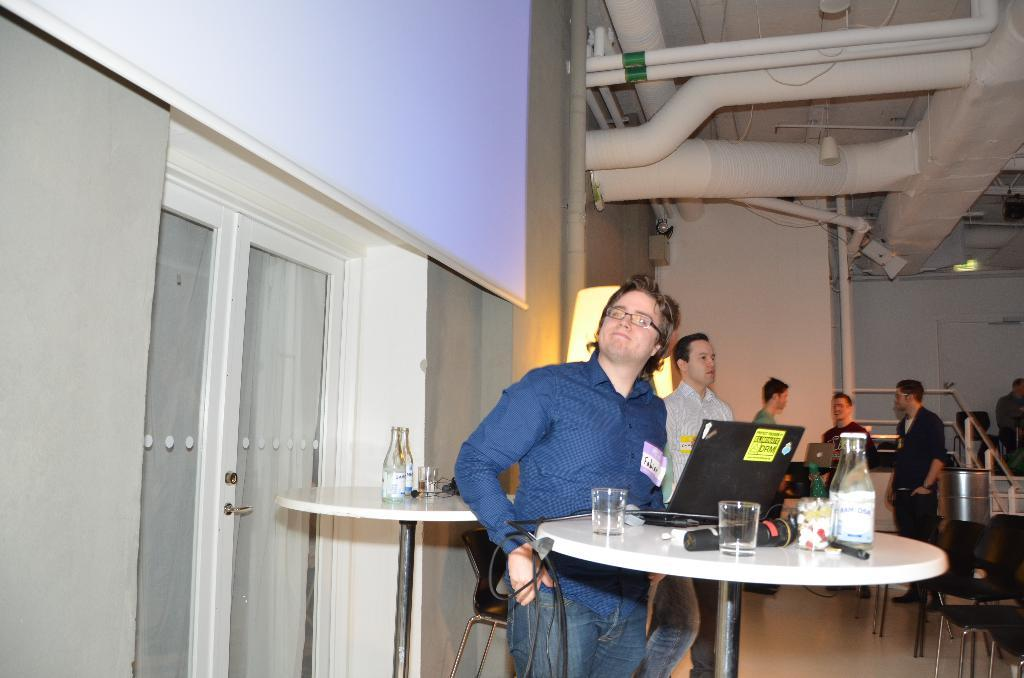What can be seen in the image regarding the people present? There are men standing in the image. What electronic device is on the table? There is a laptop on the table. What beverage container is on the table? There is a bottle on the table. What is used for drinking on the table? There is a glass on the table. What other objects are on the table? There are other objects on the table, but their specific details are not mentioned in the facts. What large container is in the image? There is a barrel in the image. What source of illumination is present? There is a light in the image. What type of infrastructure is visible? There are pipes in the image. How does the zebra turn around in the image? There is no zebra present in the image, so it cannot turn around. What type of nail is used to hold the pipes together in the image? The facts do not mention any nails being used to hold the pipes together in the image. 